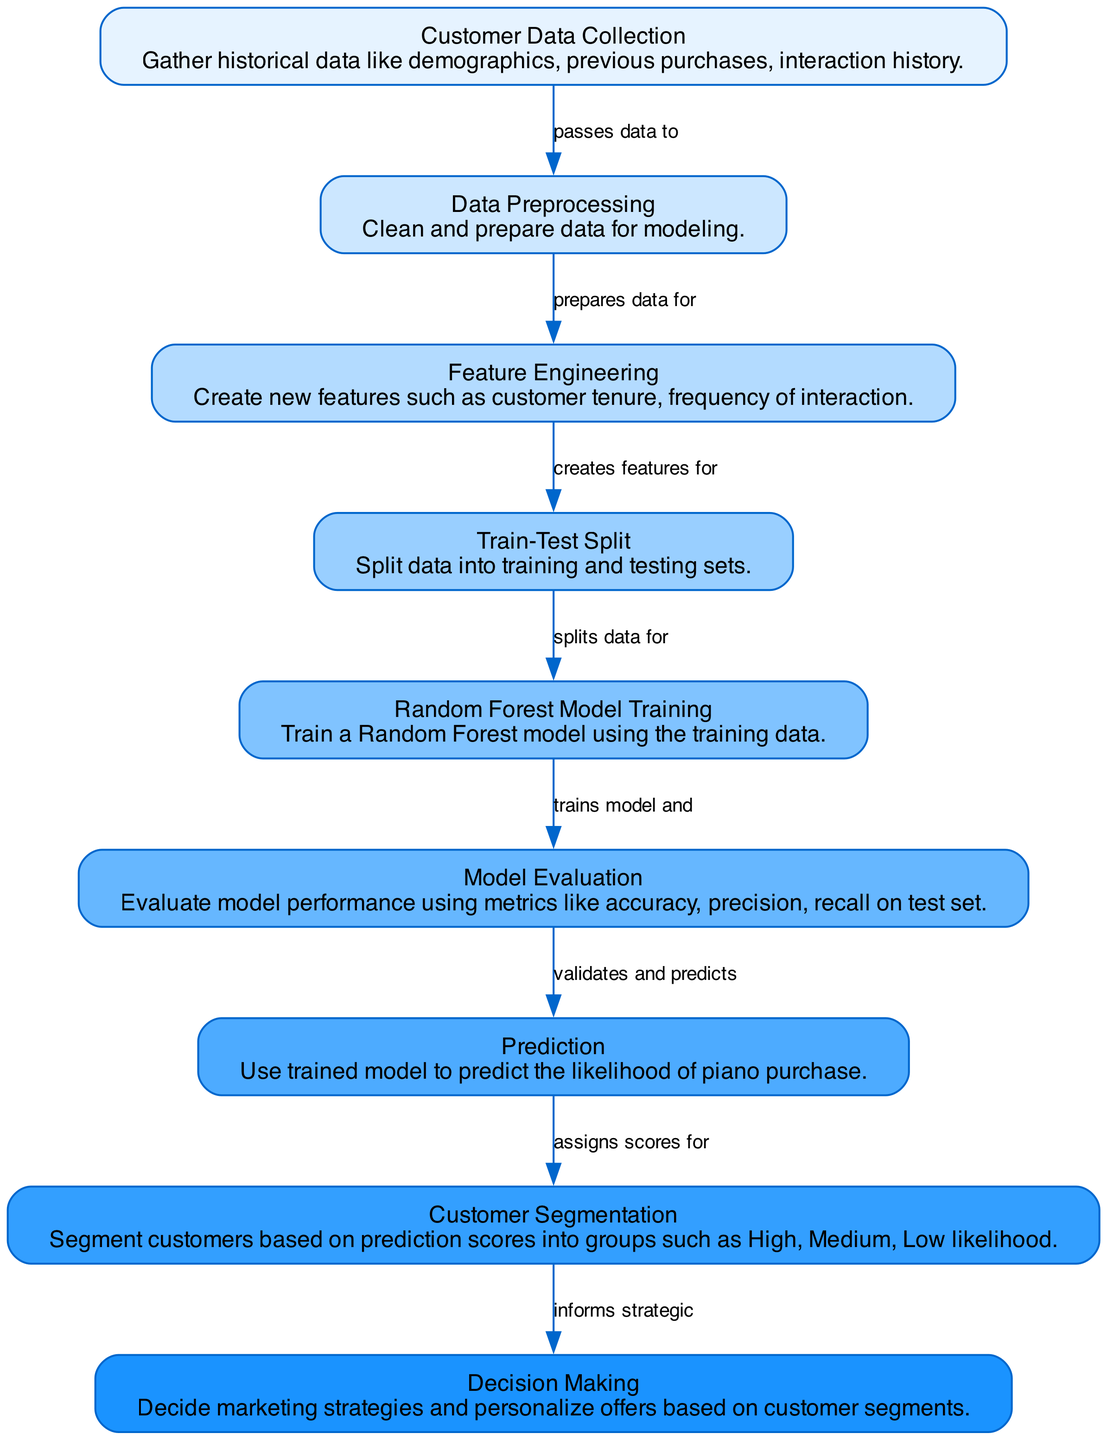What is the first step in the diagram? The first step in the diagram is labeled "Customer Data Collection," where historical data is gathered.
Answer: Customer Data Collection How many nodes are there in the diagram? There are nine nodes represented in the diagram, each detailing different steps in the process.
Answer: 9 What does the edge from "Data Preprocessing" point to? The edge originating from "Data Preprocessing" leads to the node labeled "Feature Engineering," indicating the flow of prepared data.
Answer: Feature Engineering Which node follows "Model Evaluation"? The node that follows "Model Evaluation" is labeled "Prediction," indicating the next phase after evaluating the model.
Answer: Prediction What is the final node in the diagram? The final node in the diagram is labeled "Decision Making," which indicates the conclusions drawn from customer segmentation.
Answer: Decision Making How does "Customer Segmentation" make use of prediction scores? "Customer Segmentation" takes the prediction scores to categorize customers into groups such as High, Medium, and Low likelihood of purchase.
Answer: Assigns scores for segmentation Which two nodes are directly connected to "Random Forest Model Training"? "Random Forest Model Training" is directly connected to both "Train-Test Split" and "Model Evaluation," showing the training phase and the subsequent evaluation.
Answer: Train-Test Split and Model Evaluation What is the purpose of "Feature Engineering"? The purpose of "Feature Engineering" is to create new features that help improve the model's predictive capability.
Answer: Create new features How does the diagram aid in decision-making? The diagram illustrates the entire process leading to customer segmentation, which directly informs strategic marketing decisions.
Answer: Informs strategic decisions 